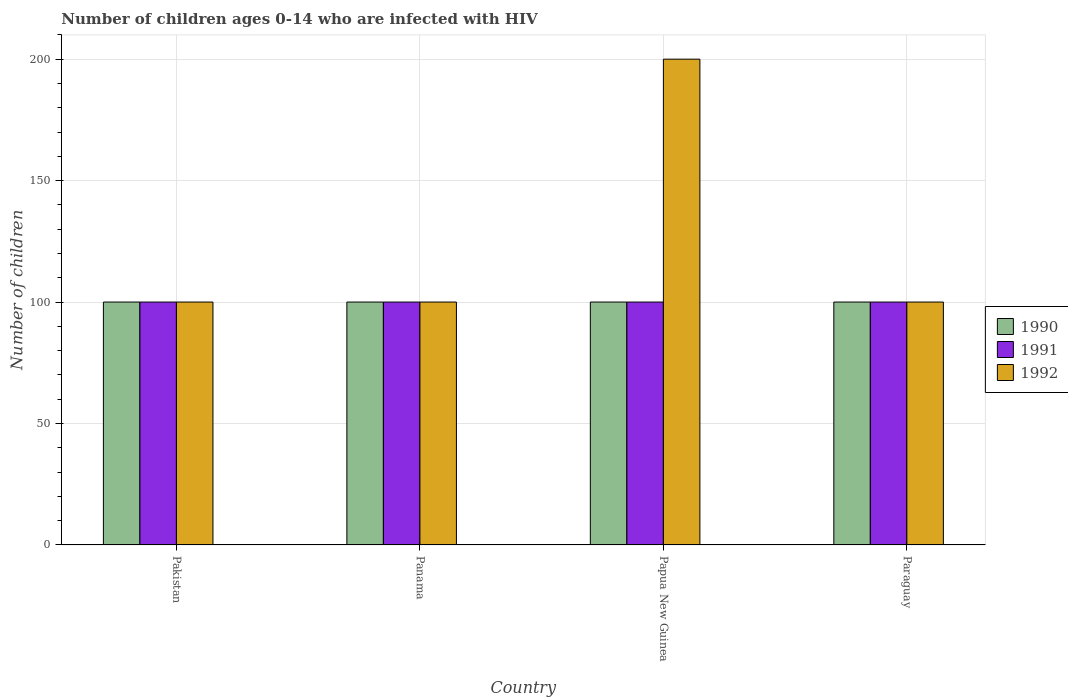How many different coloured bars are there?
Your answer should be compact. 3. How many groups of bars are there?
Keep it short and to the point. 4. Are the number of bars per tick equal to the number of legend labels?
Your response must be concise. Yes. How many bars are there on the 1st tick from the left?
Keep it short and to the point. 3. How many bars are there on the 1st tick from the right?
Your response must be concise. 3. What is the label of the 4th group of bars from the left?
Ensure brevity in your answer.  Paraguay. In how many cases, is the number of bars for a given country not equal to the number of legend labels?
Ensure brevity in your answer.  0. What is the number of HIV infected children in 1990 in Papua New Guinea?
Provide a short and direct response. 100. Across all countries, what is the maximum number of HIV infected children in 1991?
Your answer should be very brief. 100. Across all countries, what is the minimum number of HIV infected children in 1990?
Give a very brief answer. 100. In which country was the number of HIV infected children in 1991 minimum?
Offer a very short reply. Pakistan. What is the total number of HIV infected children in 1992 in the graph?
Offer a very short reply. 500. What is the difference between the number of HIV infected children of/in 1992 and number of HIV infected children of/in 1990 in Paraguay?
Your answer should be very brief. 0. In how many countries, is the number of HIV infected children in 1992 greater than 20?
Give a very brief answer. 4. Is the difference between the number of HIV infected children in 1992 in Papua New Guinea and Paraguay greater than the difference between the number of HIV infected children in 1990 in Papua New Guinea and Paraguay?
Provide a short and direct response. Yes. What is the difference between the highest and the lowest number of HIV infected children in 1992?
Keep it short and to the point. 100. In how many countries, is the number of HIV infected children in 1990 greater than the average number of HIV infected children in 1990 taken over all countries?
Your answer should be compact. 0. Is the sum of the number of HIV infected children in 1990 in Pakistan and Panama greater than the maximum number of HIV infected children in 1992 across all countries?
Your answer should be very brief. No. What does the 3rd bar from the left in Paraguay represents?
Provide a succinct answer. 1992. Is it the case that in every country, the sum of the number of HIV infected children in 1990 and number of HIV infected children in 1991 is greater than the number of HIV infected children in 1992?
Provide a short and direct response. No. How many countries are there in the graph?
Ensure brevity in your answer.  4. Does the graph contain any zero values?
Provide a succinct answer. No. Does the graph contain grids?
Your response must be concise. Yes. Where does the legend appear in the graph?
Offer a terse response. Center right. What is the title of the graph?
Offer a terse response. Number of children ages 0-14 who are infected with HIV. What is the label or title of the Y-axis?
Keep it short and to the point. Number of children. What is the Number of children in 1990 in Pakistan?
Provide a succinct answer. 100. What is the Number of children of 1991 in Pakistan?
Provide a succinct answer. 100. What is the Number of children in 1990 in Papua New Guinea?
Make the answer very short. 100. What is the Number of children in 1991 in Paraguay?
Your answer should be very brief. 100. What is the Number of children of 1992 in Paraguay?
Provide a short and direct response. 100. Across all countries, what is the maximum Number of children in 1990?
Offer a very short reply. 100. Across all countries, what is the maximum Number of children of 1991?
Your answer should be compact. 100. Across all countries, what is the maximum Number of children of 1992?
Provide a short and direct response. 200. Across all countries, what is the minimum Number of children of 1990?
Make the answer very short. 100. Across all countries, what is the minimum Number of children in 1992?
Ensure brevity in your answer.  100. What is the total Number of children in 1990 in the graph?
Offer a very short reply. 400. What is the total Number of children in 1991 in the graph?
Your answer should be very brief. 400. What is the total Number of children of 1992 in the graph?
Provide a succinct answer. 500. What is the difference between the Number of children of 1990 in Pakistan and that in Panama?
Give a very brief answer. 0. What is the difference between the Number of children in 1992 in Pakistan and that in Papua New Guinea?
Provide a short and direct response. -100. What is the difference between the Number of children in 1990 in Pakistan and that in Paraguay?
Your answer should be compact. 0. What is the difference between the Number of children of 1991 in Pakistan and that in Paraguay?
Offer a very short reply. 0. What is the difference between the Number of children in 1992 in Pakistan and that in Paraguay?
Your answer should be very brief. 0. What is the difference between the Number of children of 1992 in Panama and that in Papua New Guinea?
Your answer should be very brief. -100. What is the difference between the Number of children of 1991 in Panama and that in Paraguay?
Ensure brevity in your answer.  0. What is the difference between the Number of children in 1992 in Panama and that in Paraguay?
Offer a terse response. 0. What is the difference between the Number of children of 1990 in Papua New Guinea and that in Paraguay?
Offer a terse response. 0. What is the difference between the Number of children of 1991 in Pakistan and the Number of children of 1992 in Panama?
Offer a terse response. 0. What is the difference between the Number of children of 1990 in Pakistan and the Number of children of 1992 in Papua New Guinea?
Ensure brevity in your answer.  -100. What is the difference between the Number of children of 1991 in Pakistan and the Number of children of 1992 in Papua New Guinea?
Provide a succinct answer. -100. What is the difference between the Number of children in 1990 in Pakistan and the Number of children in 1992 in Paraguay?
Ensure brevity in your answer.  0. What is the difference between the Number of children of 1991 in Pakistan and the Number of children of 1992 in Paraguay?
Ensure brevity in your answer.  0. What is the difference between the Number of children of 1990 in Panama and the Number of children of 1992 in Papua New Guinea?
Make the answer very short. -100. What is the difference between the Number of children of 1991 in Panama and the Number of children of 1992 in Papua New Guinea?
Keep it short and to the point. -100. What is the difference between the Number of children of 1990 in Panama and the Number of children of 1991 in Paraguay?
Your answer should be compact. 0. What is the difference between the Number of children in 1990 in Panama and the Number of children in 1992 in Paraguay?
Keep it short and to the point. 0. What is the difference between the Number of children of 1991 in Panama and the Number of children of 1992 in Paraguay?
Keep it short and to the point. 0. What is the difference between the Number of children in 1990 in Papua New Guinea and the Number of children in 1991 in Paraguay?
Ensure brevity in your answer.  0. What is the average Number of children in 1992 per country?
Your answer should be compact. 125. What is the difference between the Number of children of 1991 and Number of children of 1992 in Pakistan?
Provide a succinct answer. 0. What is the difference between the Number of children in 1990 and Number of children in 1991 in Panama?
Your response must be concise. 0. What is the difference between the Number of children in 1990 and Number of children in 1992 in Panama?
Keep it short and to the point. 0. What is the difference between the Number of children of 1990 and Number of children of 1992 in Papua New Guinea?
Your answer should be very brief. -100. What is the difference between the Number of children of 1991 and Number of children of 1992 in Papua New Guinea?
Offer a very short reply. -100. What is the difference between the Number of children of 1990 and Number of children of 1991 in Paraguay?
Make the answer very short. 0. What is the ratio of the Number of children in 1991 in Pakistan to that in Panama?
Ensure brevity in your answer.  1. What is the ratio of the Number of children of 1992 in Pakistan to that in Panama?
Offer a very short reply. 1. What is the ratio of the Number of children in 1991 in Pakistan to that in Papua New Guinea?
Ensure brevity in your answer.  1. What is the ratio of the Number of children of 1992 in Pakistan to that in Papua New Guinea?
Your answer should be very brief. 0.5. What is the ratio of the Number of children of 1991 in Panama to that in Papua New Guinea?
Your response must be concise. 1. What is the ratio of the Number of children in 1992 in Panama to that in Papua New Guinea?
Offer a very short reply. 0.5. What is the ratio of the Number of children in 1990 in Papua New Guinea to that in Paraguay?
Offer a terse response. 1. What is the ratio of the Number of children of 1991 in Papua New Guinea to that in Paraguay?
Make the answer very short. 1. What is the ratio of the Number of children of 1992 in Papua New Guinea to that in Paraguay?
Provide a succinct answer. 2. What is the difference between the highest and the second highest Number of children of 1990?
Make the answer very short. 0. What is the difference between the highest and the second highest Number of children of 1992?
Provide a succinct answer. 100. What is the difference between the highest and the lowest Number of children in 1991?
Offer a terse response. 0. What is the difference between the highest and the lowest Number of children in 1992?
Give a very brief answer. 100. 